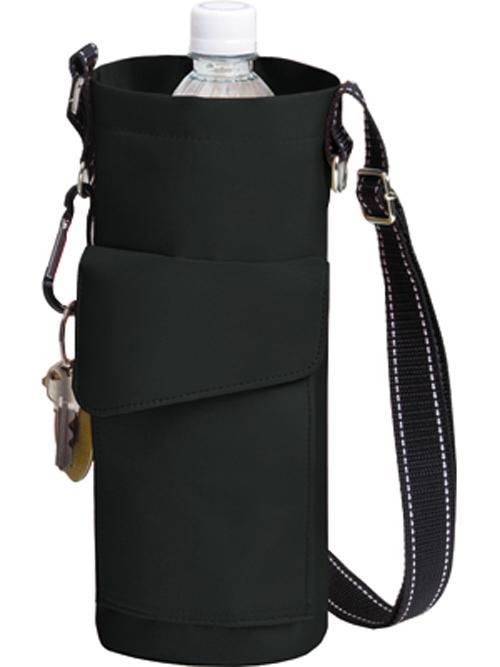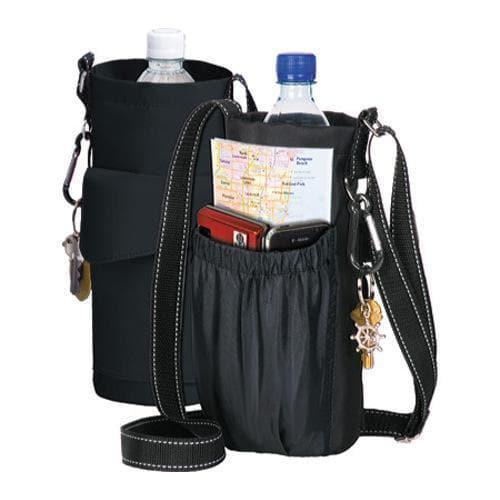The first image is the image on the left, the second image is the image on the right. For the images displayed, is the sentence "Right image includes a black bottle holder featuring a long strap and a pouch with an elasticized top, but the left image does not." factually correct? Answer yes or no. Yes. The first image is the image on the left, the second image is the image on the right. Assess this claim about the two images: "A single bottle with a cap sits in a bag in each of the images.". Correct or not? Answer yes or no. No. 